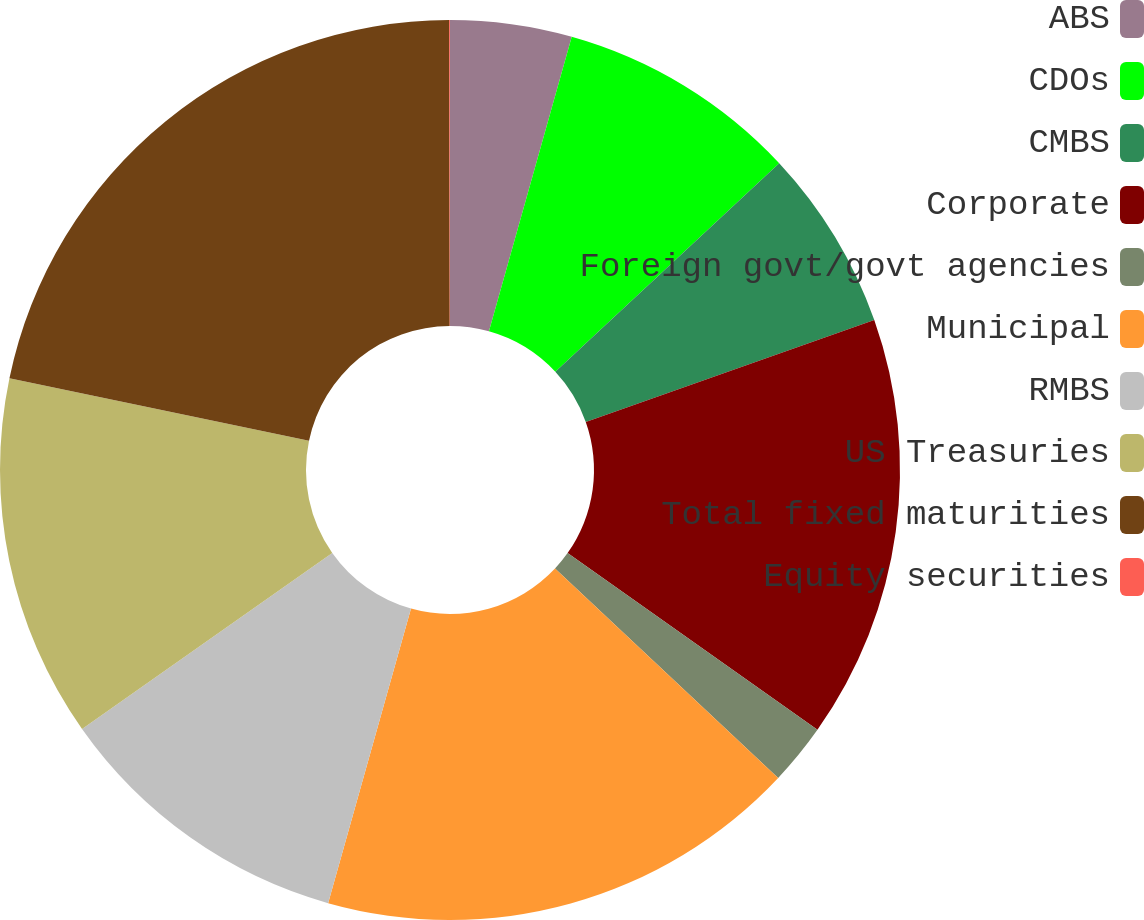<chart> <loc_0><loc_0><loc_500><loc_500><pie_chart><fcel>ABS<fcel>CDOs<fcel>CMBS<fcel>Corporate<fcel>Foreign govt/govt agencies<fcel>Municipal<fcel>RMBS<fcel>US Treasuries<fcel>Total fixed maturities<fcel>Equity securities<nl><fcel>4.36%<fcel>8.7%<fcel>6.53%<fcel>15.2%<fcel>2.2%<fcel>17.37%<fcel>10.87%<fcel>13.03%<fcel>21.7%<fcel>0.03%<nl></chart> 